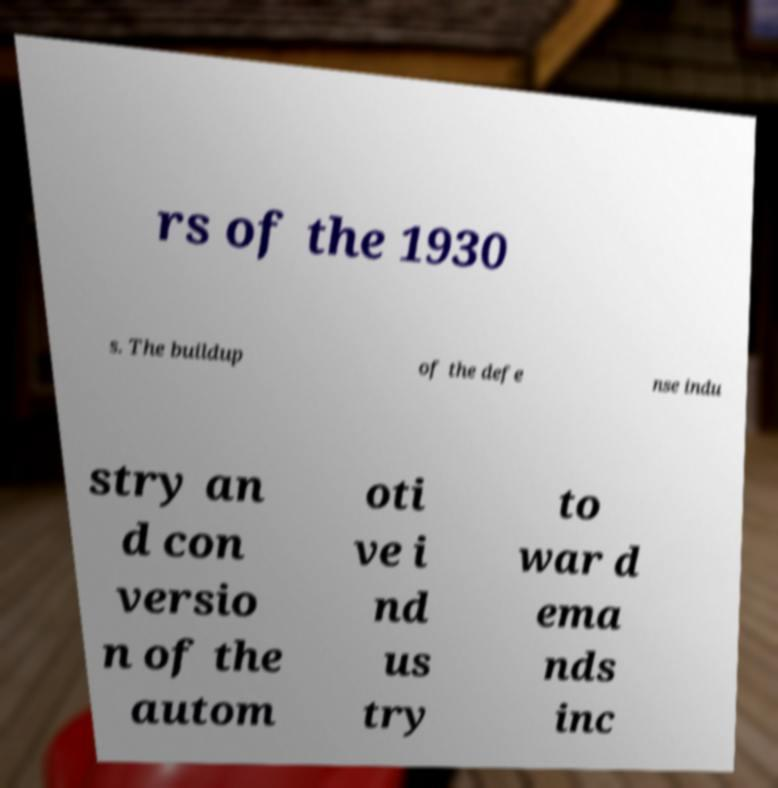Please identify and transcribe the text found in this image. rs of the 1930 s. The buildup of the defe nse indu stry an d con versio n of the autom oti ve i nd us try to war d ema nds inc 